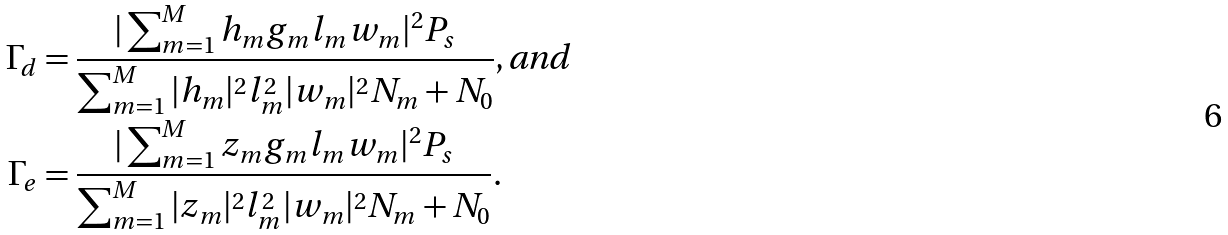<formula> <loc_0><loc_0><loc_500><loc_500>\Gamma _ { d } & = \frac { | \sum _ { m = 1 } ^ { M } h _ { m } g _ { m } l _ { m } w _ { m } | ^ { 2 } P _ { s } } { \sum _ { m = 1 } ^ { M } | h _ { m } | ^ { 2 } l _ { m } ^ { 2 } | w _ { m } | ^ { 2 } N _ { m } + N _ { 0 } } , \text {and} \\ \Gamma _ { e } & = \frac { | \sum _ { m = 1 } ^ { M } z _ { m } g _ { m } l _ { m } w _ { m } | ^ { 2 } P _ { s } } { \sum _ { m = 1 } ^ { M } | z _ { m } | ^ { 2 } l _ { m } ^ { 2 } | w _ { m } | ^ { 2 } N _ { m } + N _ { 0 } } .</formula> 